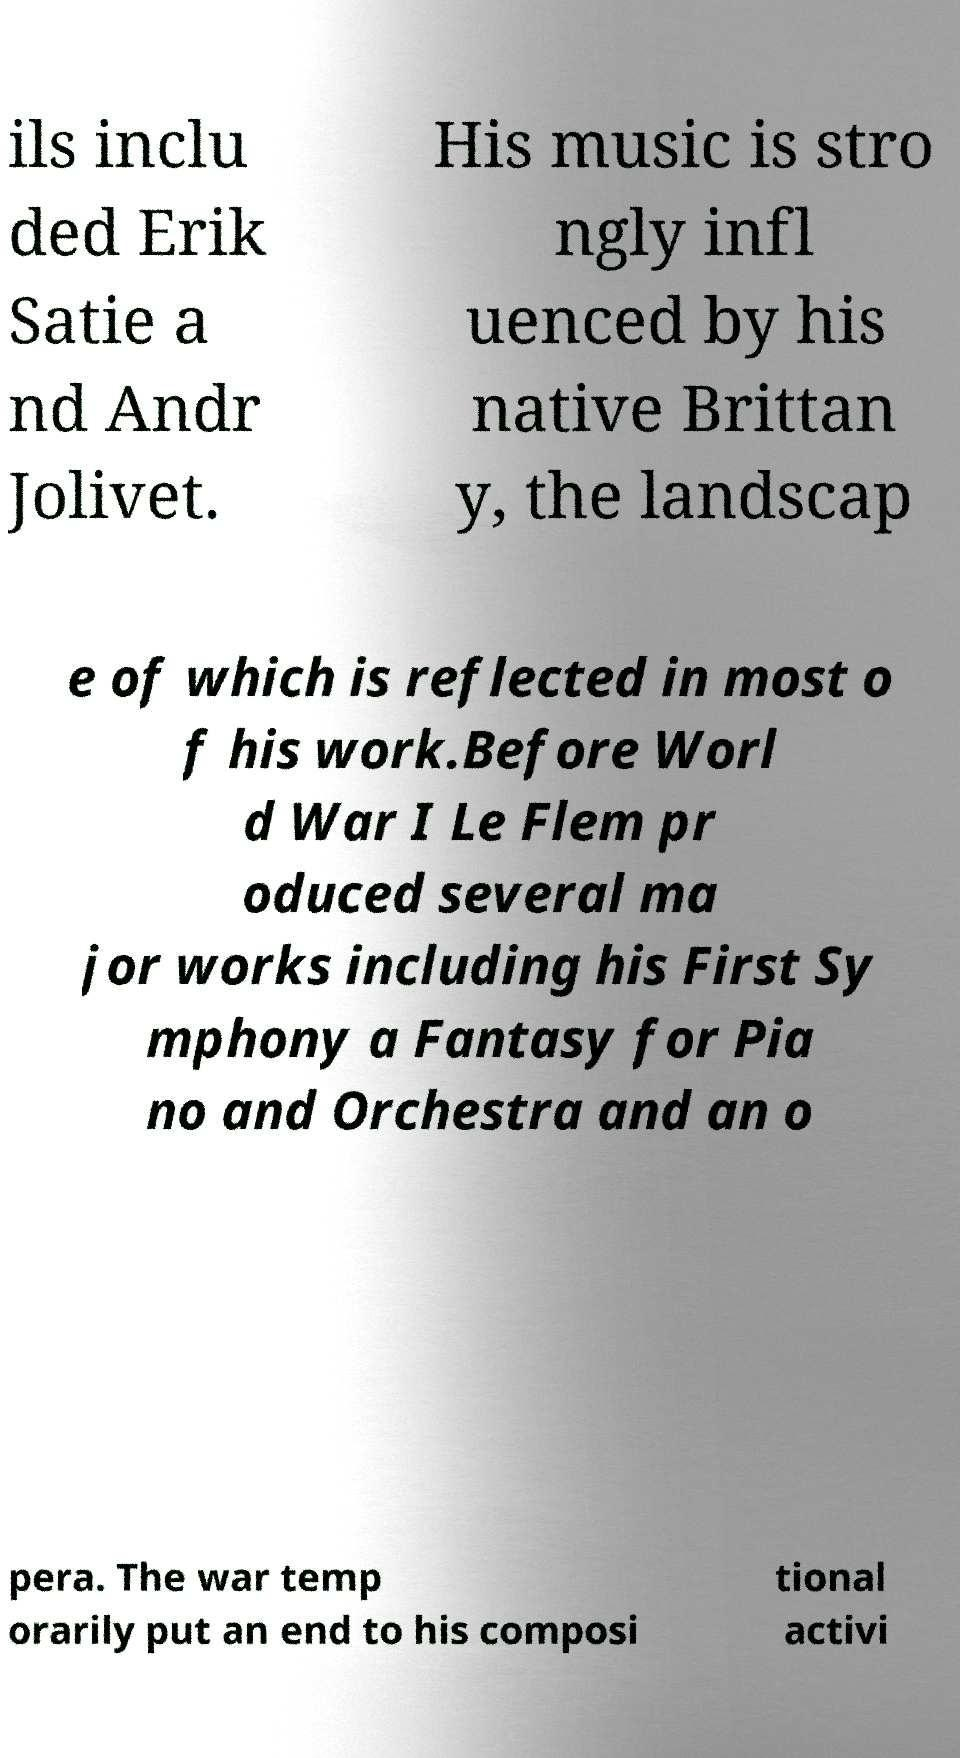Can you accurately transcribe the text from the provided image for me? ils inclu ded Erik Satie a nd Andr Jolivet. His music is stro ngly infl uenced by his native Brittan y, the landscap e of which is reflected in most o f his work.Before Worl d War I Le Flem pr oduced several ma jor works including his First Sy mphony a Fantasy for Pia no and Orchestra and an o pera. The war temp orarily put an end to his composi tional activi 